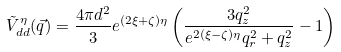Convert formula to latex. <formula><loc_0><loc_0><loc_500><loc_500>\tilde { V } ^ { \eta } _ { d d } ( \vec { q } ) = \frac { 4 \pi d ^ { 2 } } { 3 } e ^ { ( 2 \xi + \zeta ) \eta } \left ( \frac { 3 q _ { z } ^ { 2 } } { e ^ { 2 ( \xi - \zeta ) \eta } q _ { r } ^ { 2 } + q _ { z } ^ { 2 } } - 1 \right )</formula> 